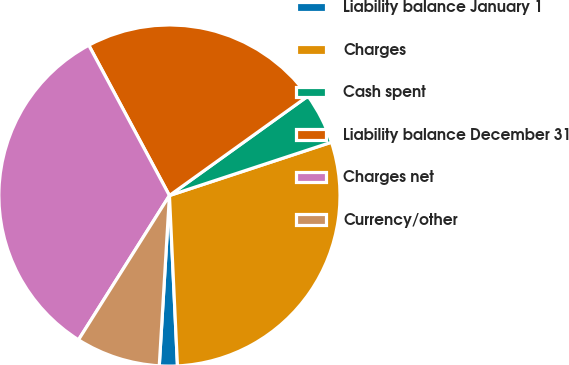Convert chart. <chart><loc_0><loc_0><loc_500><loc_500><pie_chart><fcel>Liability balance January 1<fcel>Charges<fcel>Cash spent<fcel>Liability balance December 31<fcel>Charges net<fcel>Currency/other<nl><fcel>1.7%<fcel>29.31%<fcel>4.85%<fcel>22.93%<fcel>33.21%<fcel>8.0%<nl></chart> 